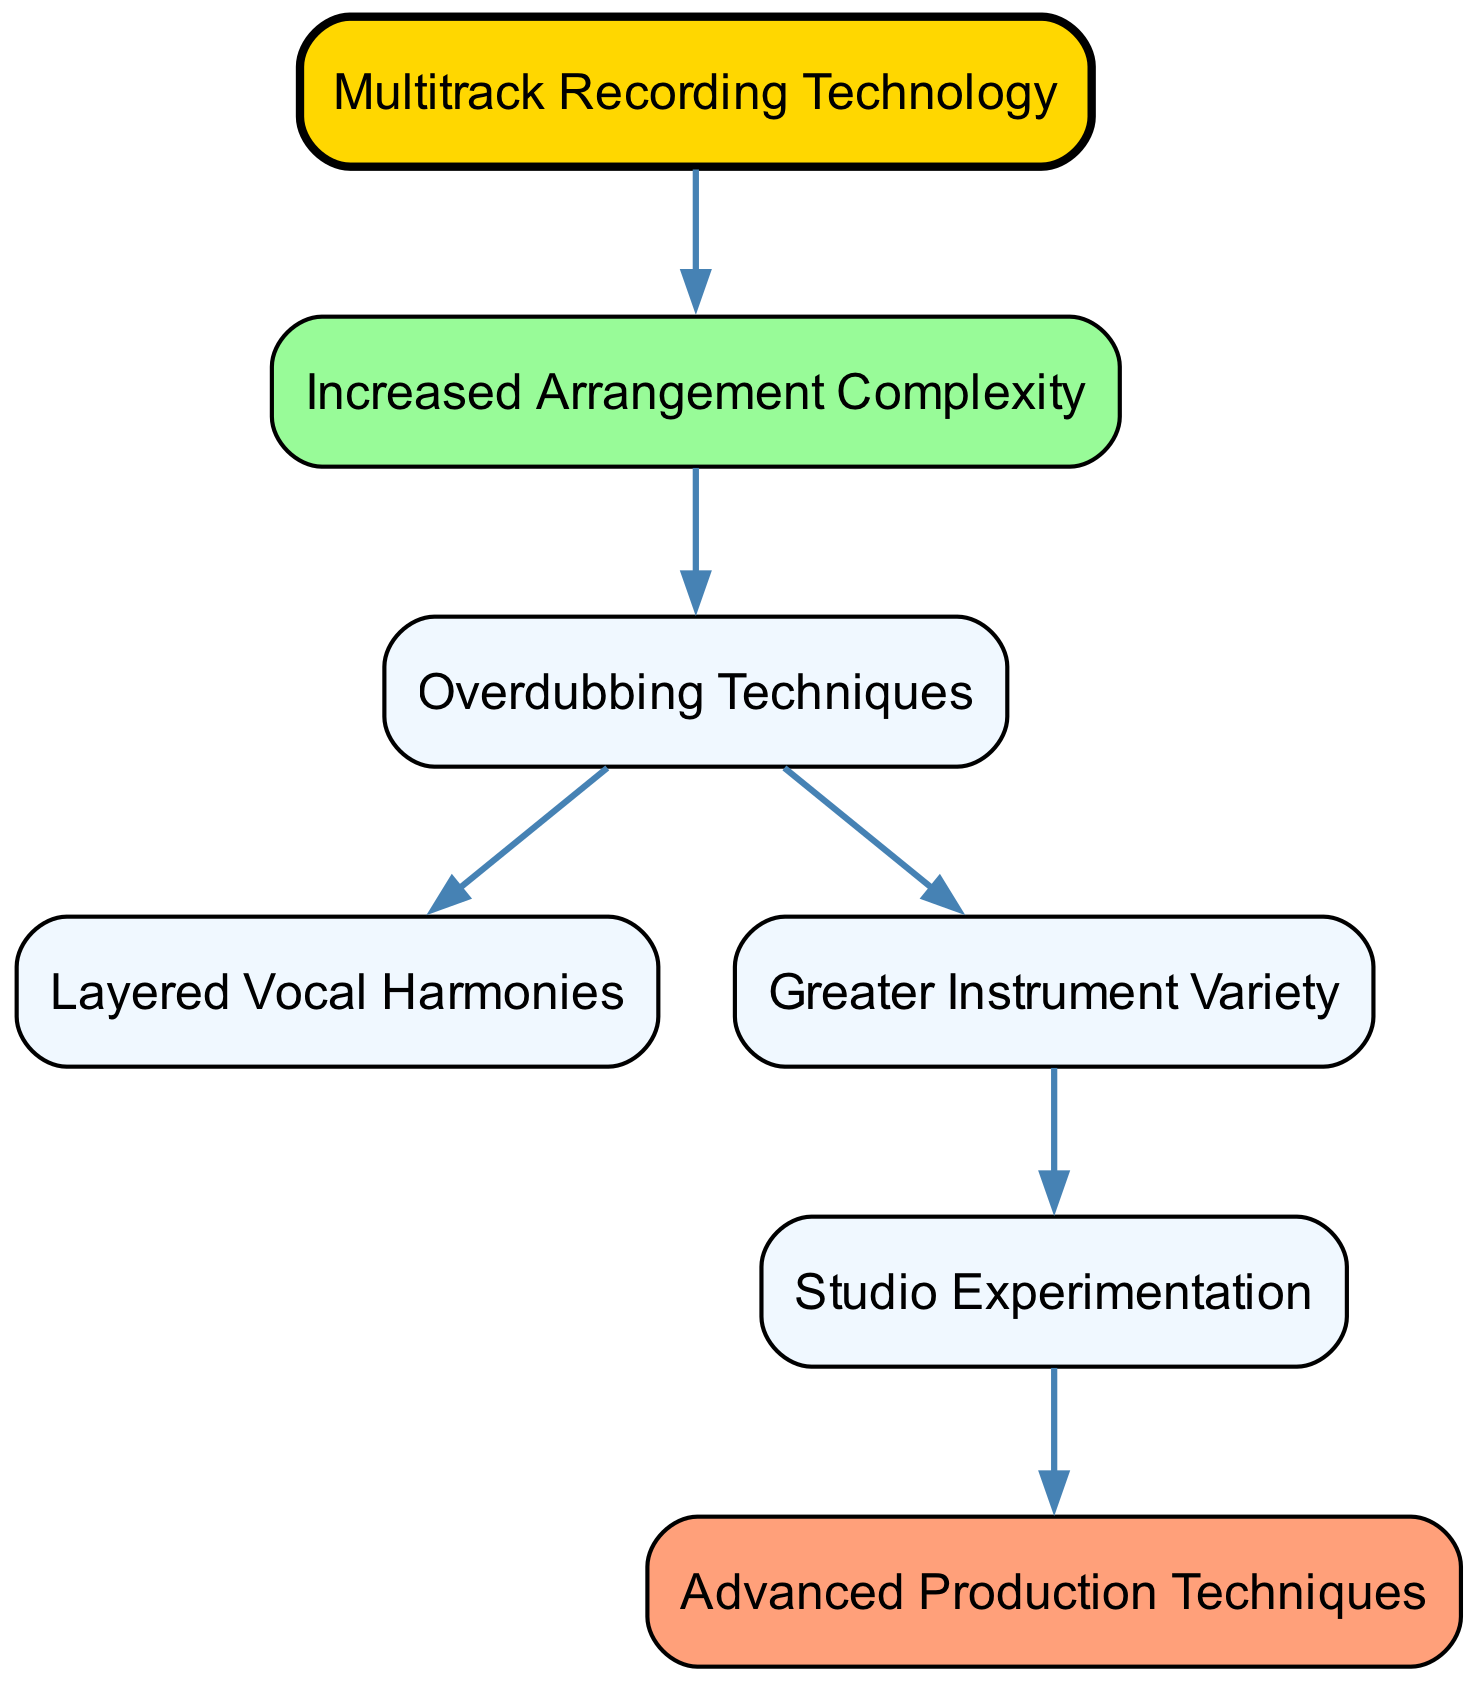What is the primary technology depicted in the diagram? The diagram centers around multitrack recording technology, which is the initial element leading to other developments. This can be identified as it is the first node in the flow of the diagram.
Answer: Multitrack Recording Technology How many edges are there in the diagram? The diagram shows a total of six relationships or connections (edges) between different elements, which can be counted by examining the connections outlined in the diagram.
Answer: 6 What is the effect of arrangement complexity on overdubbing techniques? There is a direct influence where increased arrangement complexity leads to the utilization of overdubbing techniques, as indicated by the directional edge connecting these two nodes.
Answer: Overdubbing Techniques Which element follows instrument variety in the diagram's flow? The diagram shows that studio experimentation comes after instrument variety, following the directional connection from instrument variety to studio experimentation.
Answer: Studio Experimentation What two elements are directly connected by overdubbing techniques? Overdubbing techniques connects to layered vocal harmonies and greater instrument variety, as both have direct edges leading from the overdubbing node.
Answer: Layered Vocal Harmonies, Greater Instrument Variety What is the final outcome of the connection sequence that starts with multitrack recording technology? The sequences show that multitrack recording technology eventually leads to advanced production techniques, as one can follow the directed paths from the starting element through several intermediary nodes to reach this outcome.
Answer: Advanced Production Techniques Which node is associated with greater instrument variety? The node that follows greater instrument variety in the progression is studio experimentation, which can be identified by tracing the directed edge from the instrument variety node.
Answer: Studio Experimentation What does increased arrangement complexity lead to? Increased arrangement complexity directly leads to overdubbing techniques, as indicated by the arrow connecting these two nodes, showcasing the relationship and dependency between them.
Answer: Overdubbing Techniques 